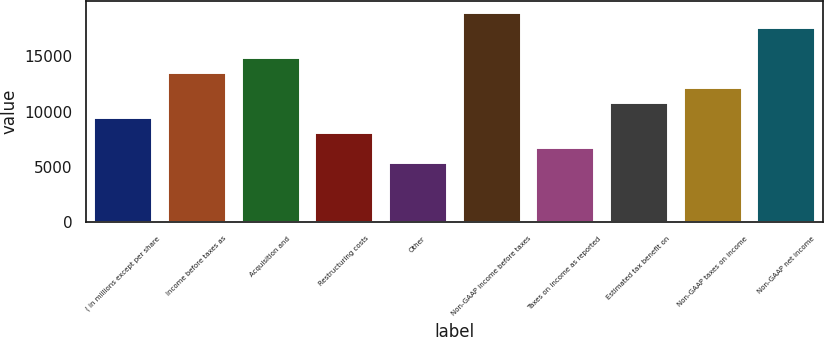Convert chart. <chart><loc_0><loc_0><loc_500><loc_500><bar_chart><fcel>( in millions except per share<fcel>Income before taxes as<fcel>Acquisition and<fcel>Restructuring costs<fcel>Other<fcel>Non-GAAP income before taxes<fcel>Taxes on income as reported<fcel>Estimated tax benefit on<fcel>Non-GAAP taxes on income<fcel>Non-GAAP net income<nl><fcel>9519.03<fcel>13598<fcel>14957.7<fcel>8159.37<fcel>5440.05<fcel>19036.7<fcel>6799.71<fcel>10878.7<fcel>12238.4<fcel>17677<nl></chart> 